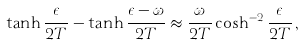Convert formula to latex. <formula><loc_0><loc_0><loc_500><loc_500>\tanh \frac { \epsilon } { 2 T } - \tanh \frac { \epsilon - \omega } { 2 T } \approx \frac { \omega } { 2 T } \cosh ^ { - 2 } \frac { \epsilon } { 2 T } \, ,</formula> 